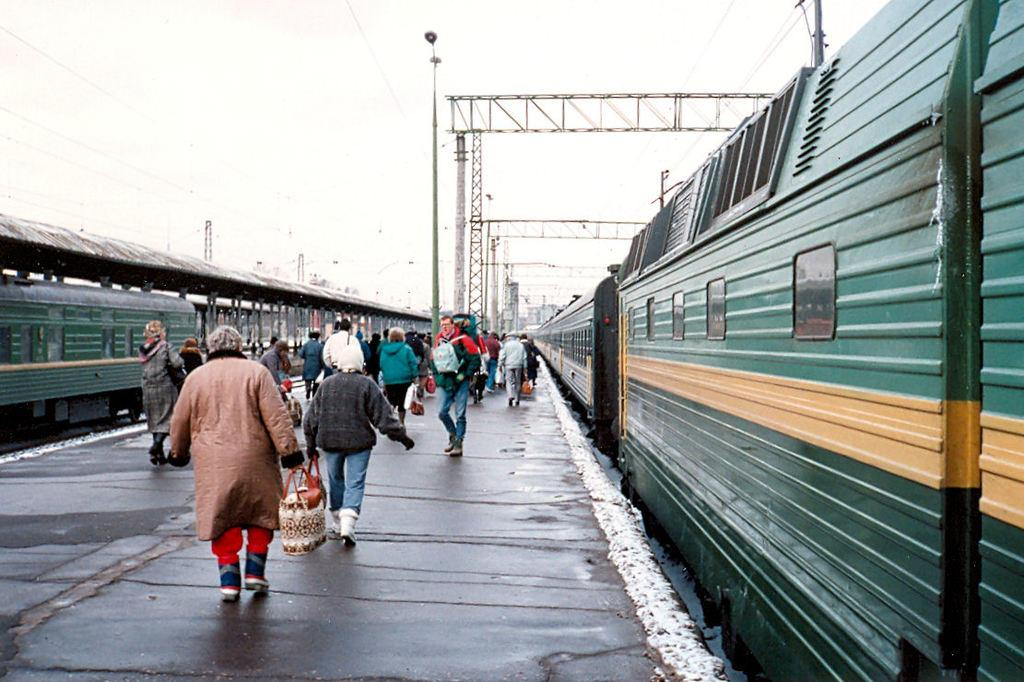What is the main subject of the image? The main subject of the image is a train. Can you describe the train's appearance? The train is green in color. Where is the train located in the image? The train is on the right side of the image. What else can be seen in the image besides the train? There are people walking in the image, and they are on a platform. Where is the platform located in the image? The platform is in the middle of the image. What is visible at the top of the image? The sky is visible at the top of the image. Can you tell me how many brushes are being used by the tiger in the image? There is no tiger or brush present in the image. What type of bag is the person carrying on the platform? The provided facts do not mention any bags being carried by the people on the platform. 